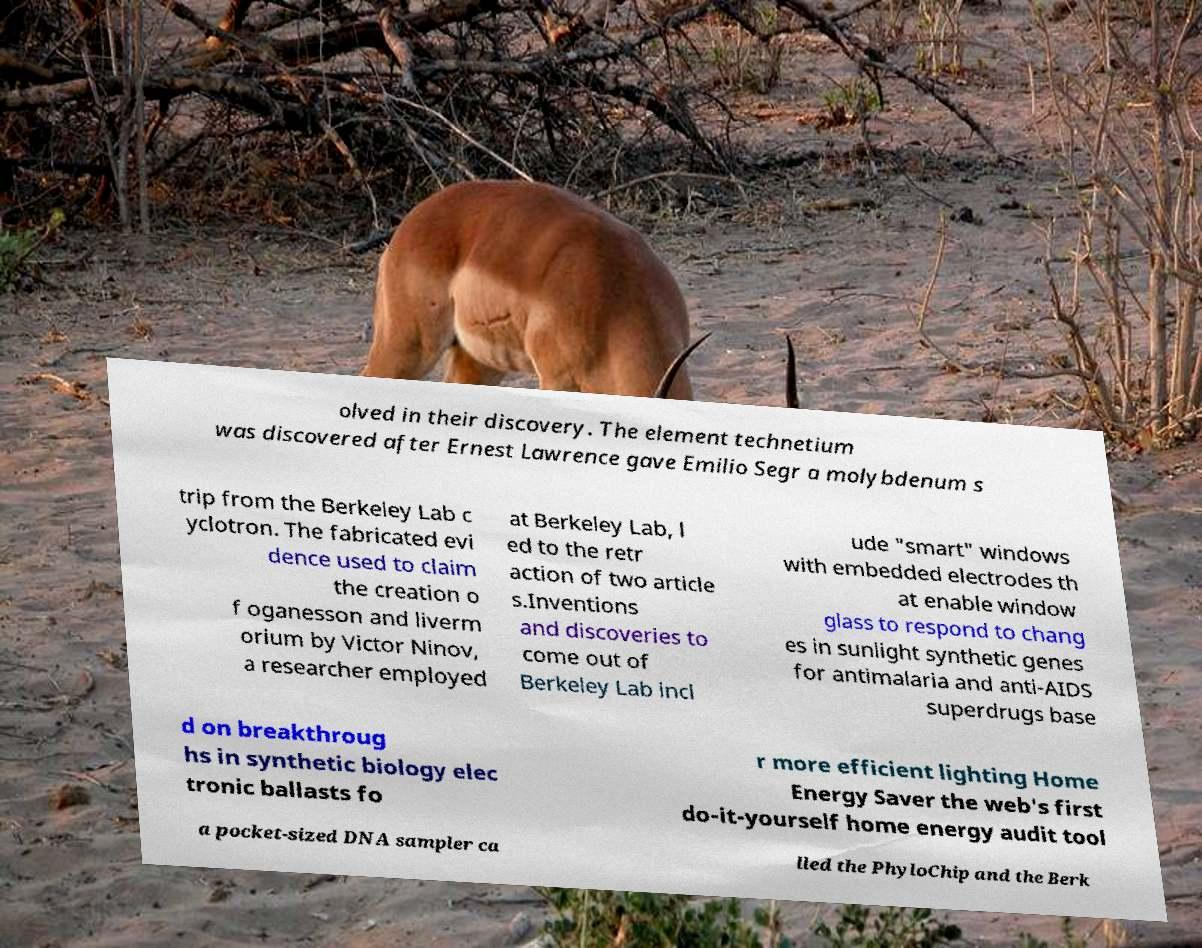There's text embedded in this image that I need extracted. Can you transcribe it verbatim? olved in their discovery. The element technetium was discovered after Ernest Lawrence gave Emilio Segr a molybdenum s trip from the Berkeley Lab c yclotron. The fabricated evi dence used to claim the creation o f oganesson and liverm orium by Victor Ninov, a researcher employed at Berkeley Lab, l ed to the retr action of two article s.Inventions and discoveries to come out of Berkeley Lab incl ude "smart" windows with embedded electrodes th at enable window glass to respond to chang es in sunlight synthetic genes for antimalaria and anti-AIDS superdrugs base d on breakthroug hs in synthetic biology elec tronic ballasts fo r more efficient lighting Home Energy Saver the web's first do-it-yourself home energy audit tool a pocket-sized DNA sampler ca lled the PhyloChip and the Berk 